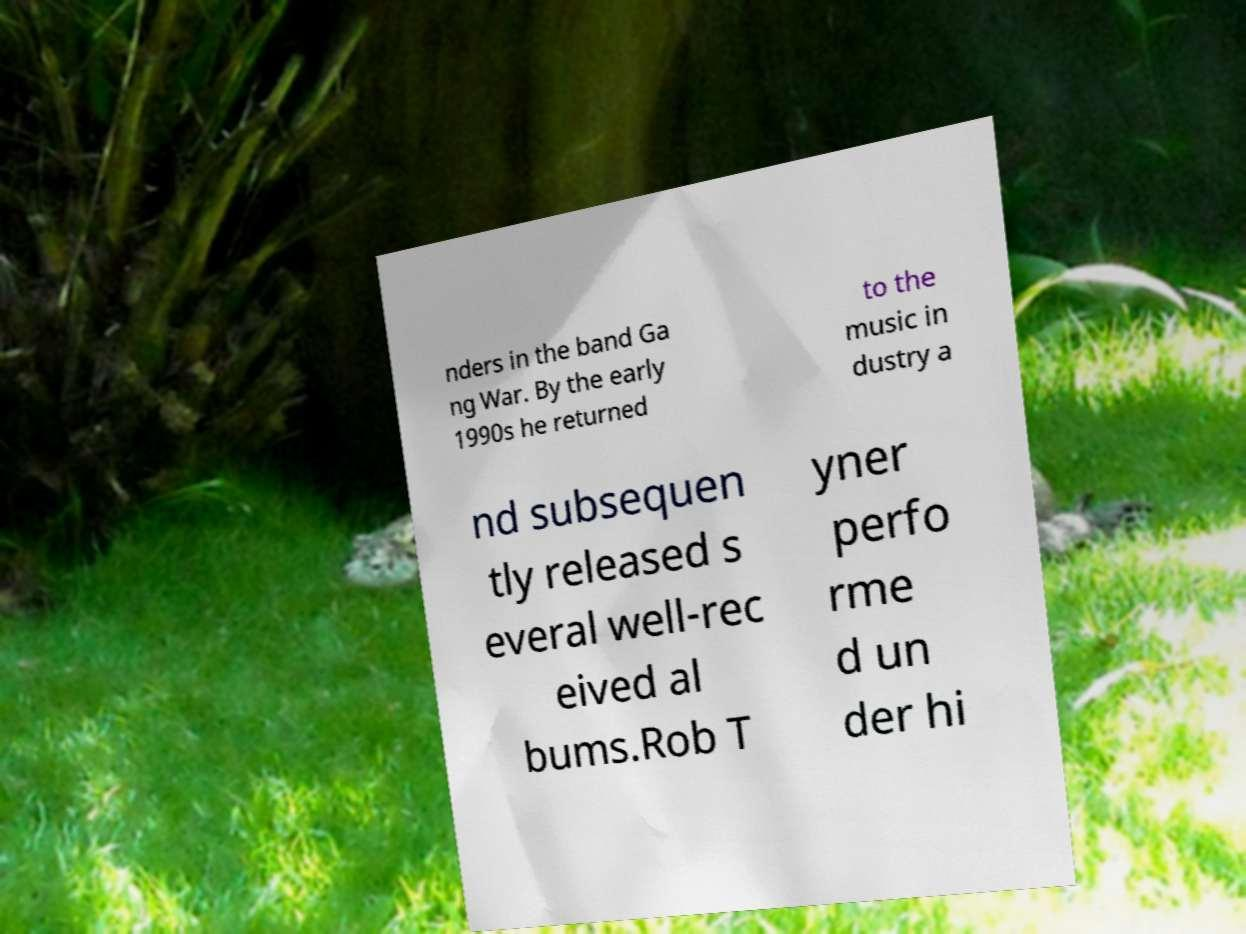For documentation purposes, I need the text within this image transcribed. Could you provide that? nders in the band Ga ng War. By the early 1990s he returned to the music in dustry a nd subsequen tly released s everal well-rec eived al bums.Rob T yner perfo rme d un der hi 